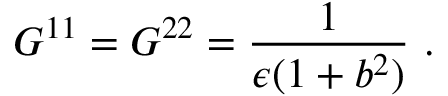Convert formula to latex. <formula><loc_0><loc_0><loc_500><loc_500>G ^ { 1 1 } = G ^ { 2 2 } = \frac { 1 } { \epsilon ( 1 + b ^ { 2 } ) } .</formula> 